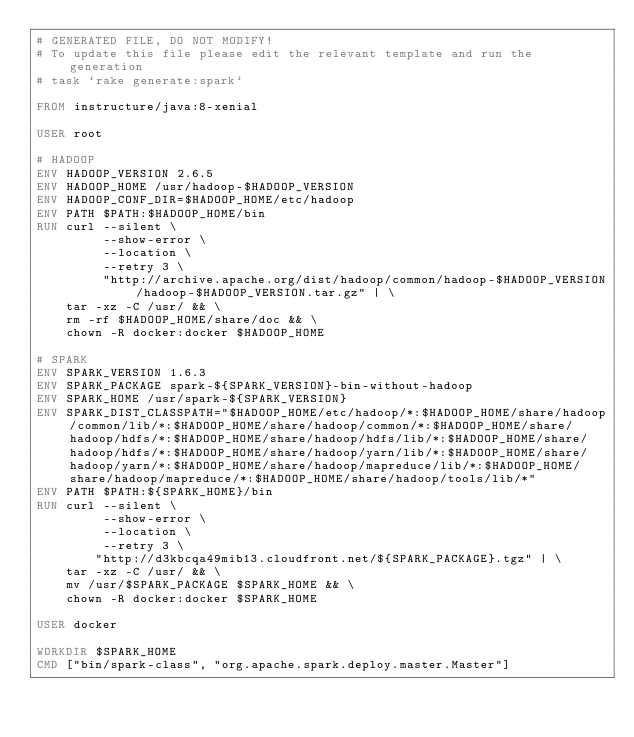<code> <loc_0><loc_0><loc_500><loc_500><_Dockerfile_># GENERATED FILE, DO NOT MODIFY!
# To update this file please edit the relevant template and run the generation
# task `rake generate:spark`

FROM instructure/java:8-xenial

USER root

# HADOOP
ENV HADOOP_VERSION 2.6.5
ENV HADOOP_HOME /usr/hadoop-$HADOOP_VERSION
ENV HADOOP_CONF_DIR=$HADOOP_HOME/etc/hadoop
ENV PATH $PATH:$HADOOP_HOME/bin
RUN curl --silent \
         --show-error \
         --location \
         --retry 3 \
         "http://archive.apache.org/dist/hadoop/common/hadoop-$HADOOP_VERSION/hadoop-$HADOOP_VERSION.tar.gz" | \
    tar -xz -C /usr/ && \
    rm -rf $HADOOP_HOME/share/doc && \
    chown -R docker:docker $HADOOP_HOME

# SPARK
ENV SPARK_VERSION 1.6.3
ENV SPARK_PACKAGE spark-${SPARK_VERSION}-bin-without-hadoop
ENV SPARK_HOME /usr/spark-${SPARK_VERSION}
ENV SPARK_DIST_CLASSPATH="$HADOOP_HOME/etc/hadoop/*:$HADOOP_HOME/share/hadoop/common/lib/*:$HADOOP_HOME/share/hadoop/common/*:$HADOOP_HOME/share/hadoop/hdfs/*:$HADOOP_HOME/share/hadoop/hdfs/lib/*:$HADOOP_HOME/share/hadoop/hdfs/*:$HADOOP_HOME/share/hadoop/yarn/lib/*:$HADOOP_HOME/share/hadoop/yarn/*:$HADOOP_HOME/share/hadoop/mapreduce/lib/*:$HADOOP_HOME/share/hadoop/mapreduce/*:$HADOOP_HOME/share/hadoop/tools/lib/*"
ENV PATH $PATH:${SPARK_HOME}/bin
RUN curl --silent \
         --show-error \
         --location \
         --retry 3 \
        "http://d3kbcqa49mib13.cloudfront.net/${SPARK_PACKAGE}.tgz" | \
    tar -xz -C /usr/ && \
    mv /usr/$SPARK_PACKAGE $SPARK_HOME && \
    chown -R docker:docker $SPARK_HOME

USER docker

WORKDIR $SPARK_HOME
CMD ["bin/spark-class", "org.apache.spark.deploy.master.Master"]
</code> 